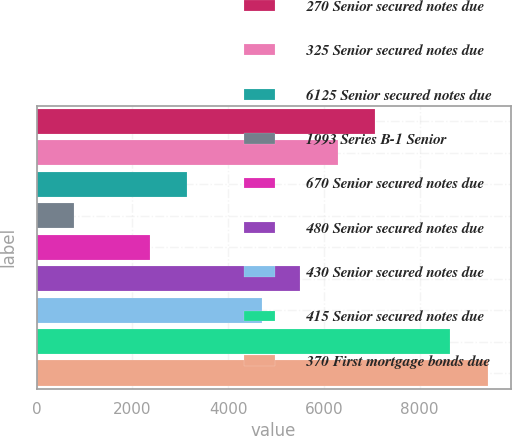Convert chart to OTSL. <chart><loc_0><loc_0><loc_500><loc_500><bar_chart><fcel>270 Senior secured notes due<fcel>325 Senior secured notes due<fcel>6125 Senior secured notes due<fcel>1993 Series B-1 Senior<fcel>670 Senior secured notes due<fcel>480 Senior secured notes due<fcel>430 Senior secured notes due<fcel>415 Senior secured notes due<fcel>370 First mortgage bonds due<nl><fcel>7073.4<fcel>6287.8<fcel>3145.4<fcel>788.6<fcel>2359.8<fcel>5502.2<fcel>4716.6<fcel>8644.6<fcel>9430.2<nl></chart> 